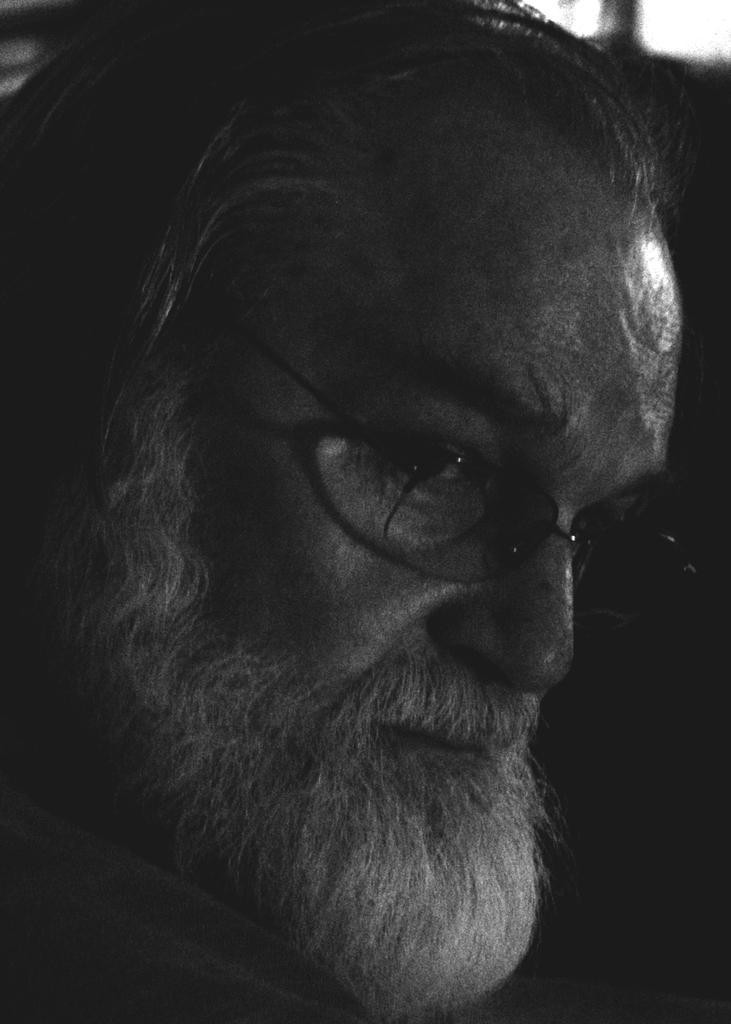Please provide a concise description of this image. This is a black and white image where I can see a person´s face wearing spectacles and he is having a beard and mustache. 